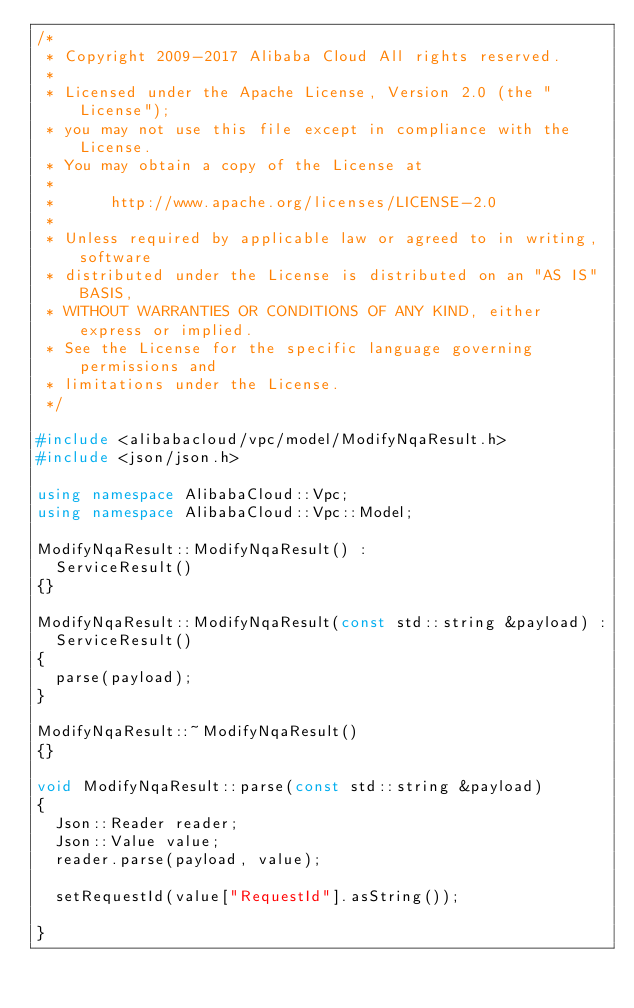<code> <loc_0><loc_0><loc_500><loc_500><_C++_>/*
 * Copyright 2009-2017 Alibaba Cloud All rights reserved.
 * 
 * Licensed under the Apache License, Version 2.0 (the "License");
 * you may not use this file except in compliance with the License.
 * You may obtain a copy of the License at
 * 
 *      http://www.apache.org/licenses/LICENSE-2.0
 * 
 * Unless required by applicable law or agreed to in writing, software
 * distributed under the License is distributed on an "AS IS" BASIS,
 * WITHOUT WARRANTIES OR CONDITIONS OF ANY KIND, either express or implied.
 * See the License for the specific language governing permissions and
 * limitations under the License.
 */

#include <alibabacloud/vpc/model/ModifyNqaResult.h>
#include <json/json.h>

using namespace AlibabaCloud::Vpc;
using namespace AlibabaCloud::Vpc::Model;

ModifyNqaResult::ModifyNqaResult() :
	ServiceResult()
{}

ModifyNqaResult::ModifyNqaResult(const std::string &payload) :
	ServiceResult()
{
	parse(payload);
}

ModifyNqaResult::~ModifyNqaResult()
{}

void ModifyNqaResult::parse(const std::string &payload)
{
	Json::Reader reader;
	Json::Value value;
	reader.parse(payload, value);

	setRequestId(value["RequestId"].asString());

}

</code> 